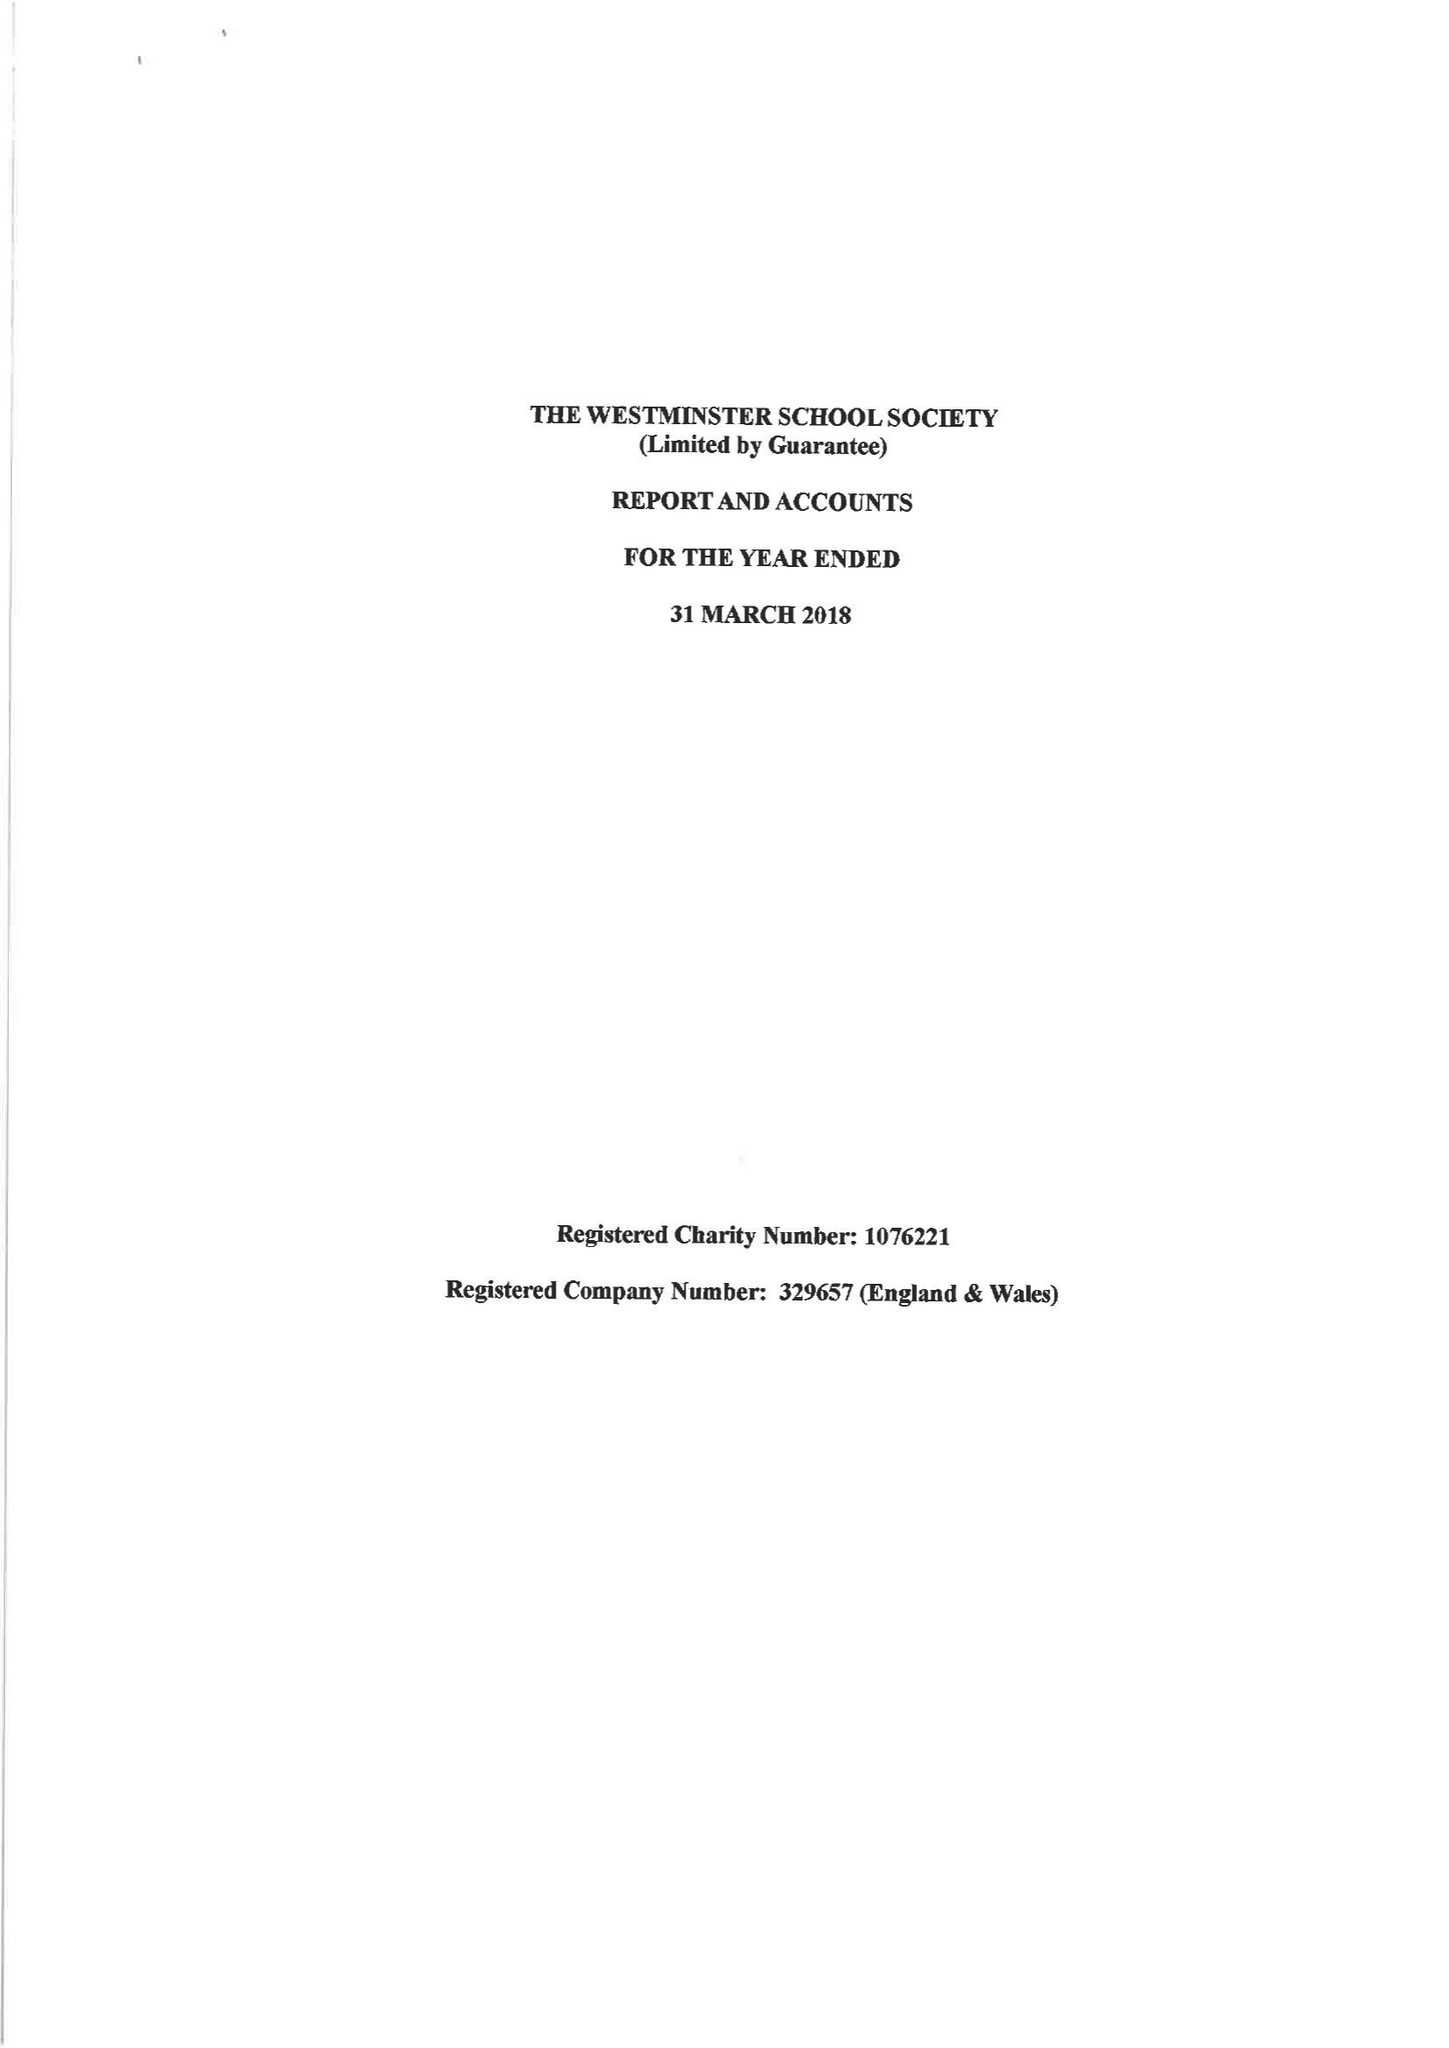What is the value for the address__street_line?
Answer the question using a single word or phrase. None 